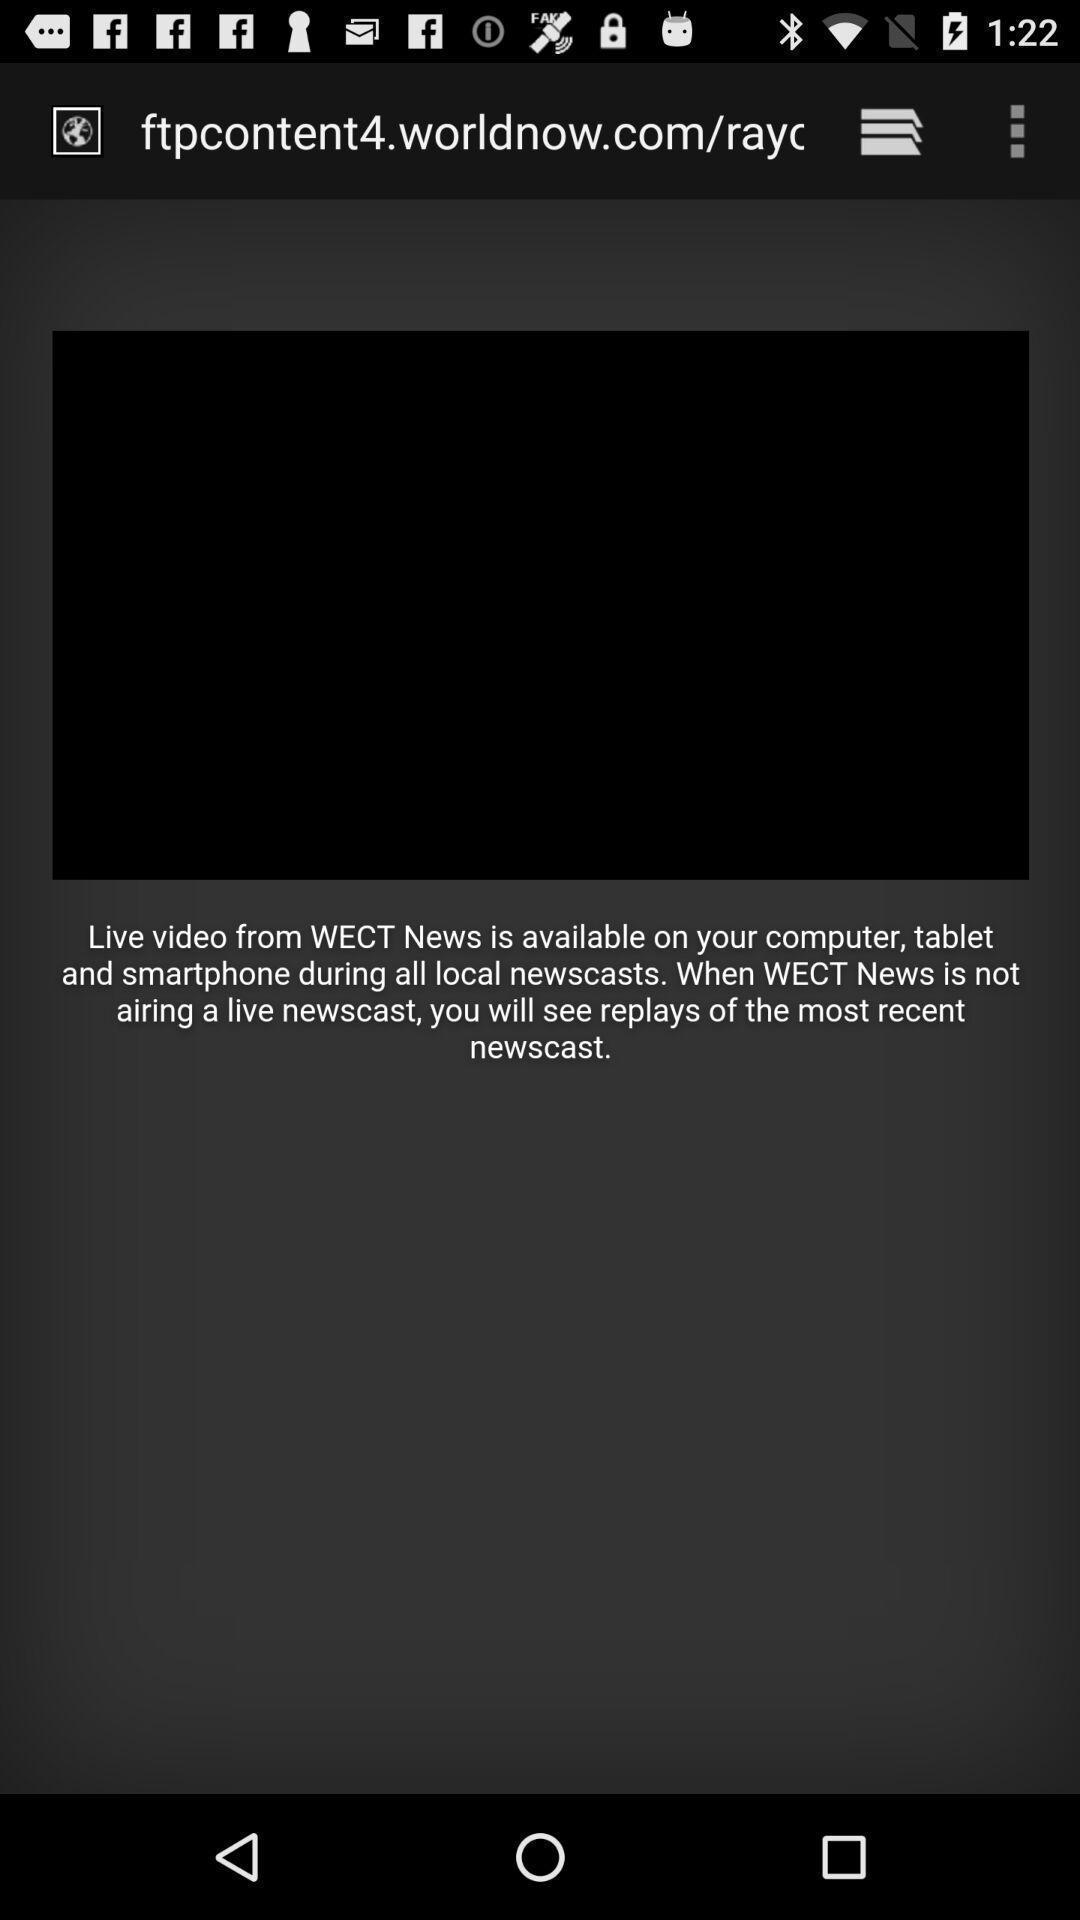Describe the content in this image. Screen display shows the live news application. 